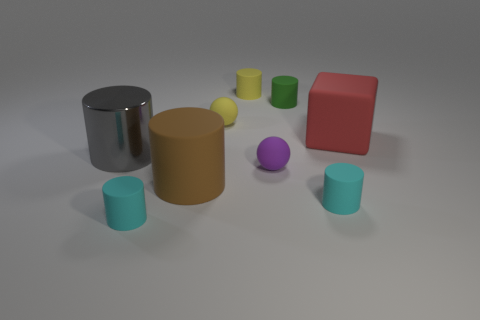Is there any other thing that is made of the same material as the large gray cylinder?
Provide a succinct answer. No. What is the size of the green cylinder that is made of the same material as the brown object?
Give a very brief answer. Small. What color is the large block?
Your answer should be very brief. Red. What material is the yellow cylinder that is the same size as the green cylinder?
Ensure brevity in your answer.  Rubber. There is a large thing in front of the big gray thing; is there a cylinder that is in front of it?
Provide a succinct answer. Yes. What size is the purple matte thing?
Ensure brevity in your answer.  Small. Are there any large blue shiny cylinders?
Make the answer very short. No. Are there more big brown rubber cylinders behind the red matte block than brown objects that are left of the big gray metallic cylinder?
Ensure brevity in your answer.  No. What material is the object that is both in front of the large metal thing and behind the brown matte cylinder?
Offer a terse response. Rubber. Does the large brown thing have the same shape as the large red thing?
Offer a very short reply. No. 